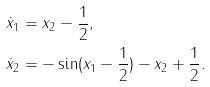Convert formula to latex. <formula><loc_0><loc_0><loc_500><loc_500>\dot { x } _ { 1 } & = x _ { 2 } - \frac { 1 } { 2 } , \\ \dot { x } _ { 2 } & = - \sin ( x _ { 1 } - \frac { 1 } { 2 } ) - x _ { 2 } + \frac { 1 } { 2 } .</formula> 